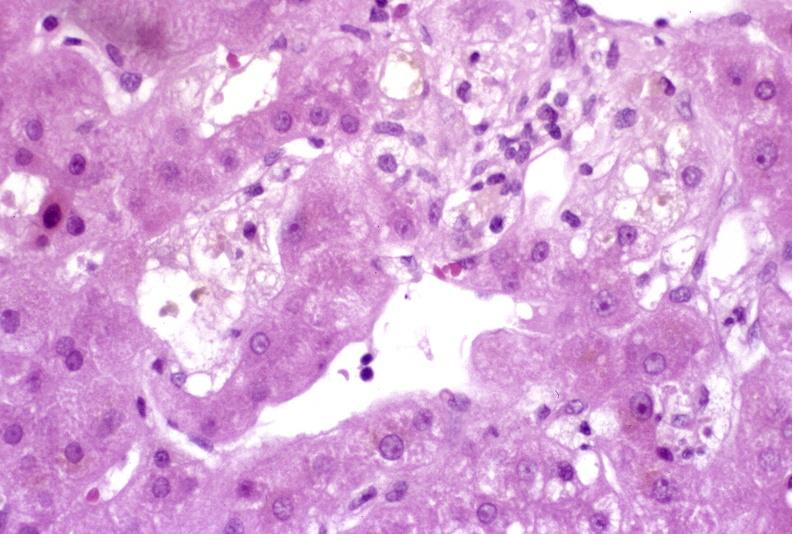what is present?
Answer the question using a single word or phrase. Liver 